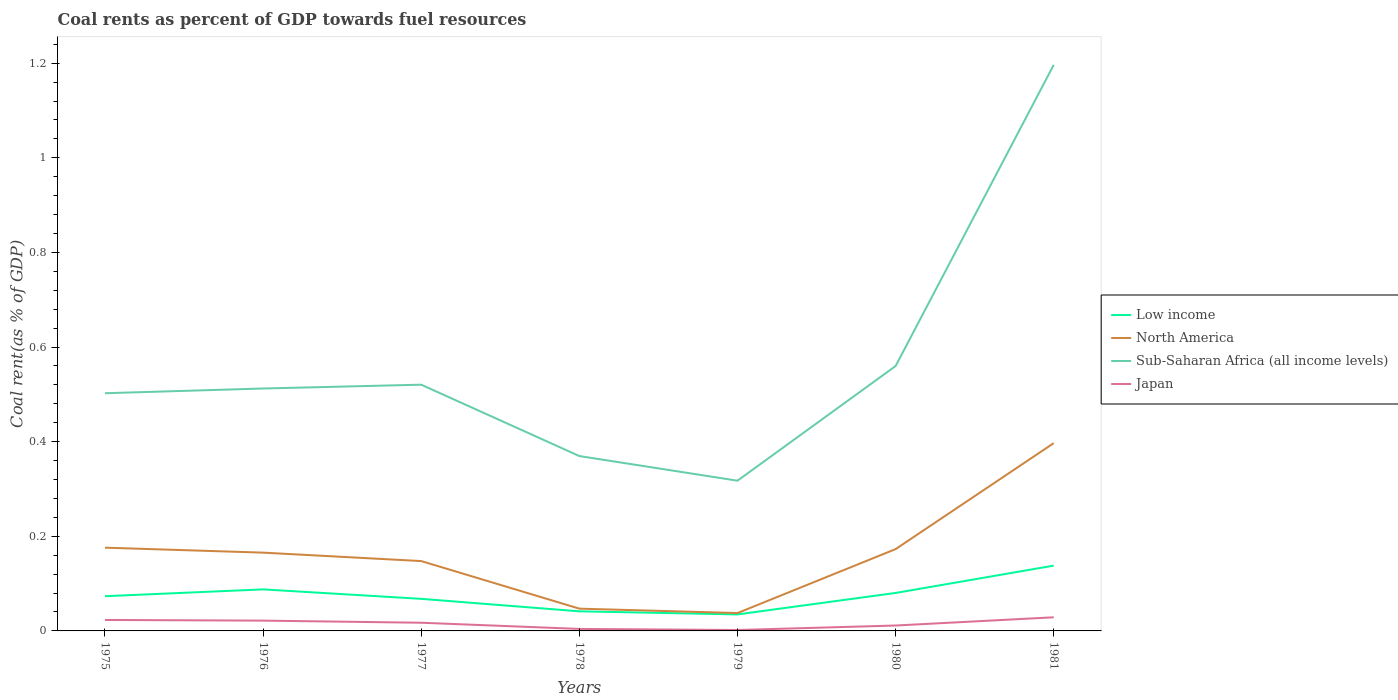Does the line corresponding to Low income intersect with the line corresponding to Japan?
Provide a succinct answer. No. Is the number of lines equal to the number of legend labels?
Make the answer very short. Yes. Across all years, what is the maximum coal rent in Japan?
Make the answer very short. 0. In which year was the coal rent in Sub-Saharan Africa (all income levels) maximum?
Your answer should be compact. 1979. What is the total coal rent in Sub-Saharan Africa (all income levels) in the graph?
Your answer should be very brief. 0.14. What is the difference between the highest and the second highest coal rent in North America?
Keep it short and to the point. 0.36. What is the difference between the highest and the lowest coal rent in North America?
Your response must be concise. 4. How many lines are there?
Ensure brevity in your answer.  4. What is the difference between two consecutive major ticks on the Y-axis?
Ensure brevity in your answer.  0.2. Does the graph contain any zero values?
Provide a short and direct response. No. Where does the legend appear in the graph?
Ensure brevity in your answer.  Center right. How many legend labels are there?
Make the answer very short. 4. How are the legend labels stacked?
Keep it short and to the point. Vertical. What is the title of the graph?
Make the answer very short. Coal rents as percent of GDP towards fuel resources. What is the label or title of the X-axis?
Ensure brevity in your answer.  Years. What is the label or title of the Y-axis?
Your answer should be compact. Coal rent(as % of GDP). What is the Coal rent(as % of GDP) of Low income in 1975?
Make the answer very short. 0.07. What is the Coal rent(as % of GDP) of North America in 1975?
Ensure brevity in your answer.  0.18. What is the Coal rent(as % of GDP) in Sub-Saharan Africa (all income levels) in 1975?
Offer a very short reply. 0.5. What is the Coal rent(as % of GDP) of Japan in 1975?
Offer a very short reply. 0.02. What is the Coal rent(as % of GDP) in Low income in 1976?
Ensure brevity in your answer.  0.09. What is the Coal rent(as % of GDP) of North America in 1976?
Offer a very short reply. 0.17. What is the Coal rent(as % of GDP) of Sub-Saharan Africa (all income levels) in 1976?
Make the answer very short. 0.51. What is the Coal rent(as % of GDP) in Japan in 1976?
Provide a succinct answer. 0.02. What is the Coal rent(as % of GDP) of Low income in 1977?
Your answer should be compact. 0.07. What is the Coal rent(as % of GDP) in North America in 1977?
Offer a very short reply. 0.15. What is the Coal rent(as % of GDP) in Sub-Saharan Africa (all income levels) in 1977?
Your answer should be very brief. 0.52. What is the Coal rent(as % of GDP) of Japan in 1977?
Offer a very short reply. 0.02. What is the Coal rent(as % of GDP) of Low income in 1978?
Make the answer very short. 0.04. What is the Coal rent(as % of GDP) of North America in 1978?
Your response must be concise. 0.05. What is the Coal rent(as % of GDP) of Sub-Saharan Africa (all income levels) in 1978?
Your answer should be very brief. 0.37. What is the Coal rent(as % of GDP) of Japan in 1978?
Offer a terse response. 0. What is the Coal rent(as % of GDP) in Low income in 1979?
Your answer should be compact. 0.03. What is the Coal rent(as % of GDP) of North America in 1979?
Provide a succinct answer. 0.04. What is the Coal rent(as % of GDP) in Sub-Saharan Africa (all income levels) in 1979?
Give a very brief answer. 0.32. What is the Coal rent(as % of GDP) in Japan in 1979?
Your answer should be compact. 0. What is the Coal rent(as % of GDP) in Low income in 1980?
Offer a very short reply. 0.08. What is the Coal rent(as % of GDP) of North America in 1980?
Your answer should be very brief. 0.17. What is the Coal rent(as % of GDP) of Sub-Saharan Africa (all income levels) in 1980?
Your response must be concise. 0.56. What is the Coal rent(as % of GDP) of Japan in 1980?
Keep it short and to the point. 0.01. What is the Coal rent(as % of GDP) in Low income in 1981?
Your answer should be very brief. 0.14. What is the Coal rent(as % of GDP) in North America in 1981?
Keep it short and to the point. 0.4. What is the Coal rent(as % of GDP) in Sub-Saharan Africa (all income levels) in 1981?
Offer a terse response. 1.2. What is the Coal rent(as % of GDP) of Japan in 1981?
Make the answer very short. 0.03. Across all years, what is the maximum Coal rent(as % of GDP) in Low income?
Keep it short and to the point. 0.14. Across all years, what is the maximum Coal rent(as % of GDP) in North America?
Give a very brief answer. 0.4. Across all years, what is the maximum Coal rent(as % of GDP) in Sub-Saharan Africa (all income levels)?
Ensure brevity in your answer.  1.2. Across all years, what is the maximum Coal rent(as % of GDP) of Japan?
Provide a short and direct response. 0.03. Across all years, what is the minimum Coal rent(as % of GDP) in Low income?
Your answer should be very brief. 0.03. Across all years, what is the minimum Coal rent(as % of GDP) in North America?
Give a very brief answer. 0.04. Across all years, what is the minimum Coal rent(as % of GDP) in Sub-Saharan Africa (all income levels)?
Provide a succinct answer. 0.32. Across all years, what is the minimum Coal rent(as % of GDP) of Japan?
Your response must be concise. 0. What is the total Coal rent(as % of GDP) of Low income in the graph?
Your answer should be very brief. 0.52. What is the total Coal rent(as % of GDP) in North America in the graph?
Your answer should be compact. 1.14. What is the total Coal rent(as % of GDP) of Sub-Saharan Africa (all income levels) in the graph?
Provide a succinct answer. 3.98. What is the total Coal rent(as % of GDP) in Japan in the graph?
Make the answer very short. 0.11. What is the difference between the Coal rent(as % of GDP) in Low income in 1975 and that in 1976?
Ensure brevity in your answer.  -0.01. What is the difference between the Coal rent(as % of GDP) in North America in 1975 and that in 1976?
Make the answer very short. 0.01. What is the difference between the Coal rent(as % of GDP) of Sub-Saharan Africa (all income levels) in 1975 and that in 1976?
Provide a short and direct response. -0.01. What is the difference between the Coal rent(as % of GDP) of Japan in 1975 and that in 1976?
Provide a succinct answer. 0. What is the difference between the Coal rent(as % of GDP) in Low income in 1975 and that in 1977?
Give a very brief answer. 0.01. What is the difference between the Coal rent(as % of GDP) in North America in 1975 and that in 1977?
Provide a succinct answer. 0.03. What is the difference between the Coal rent(as % of GDP) in Sub-Saharan Africa (all income levels) in 1975 and that in 1977?
Provide a short and direct response. -0.02. What is the difference between the Coal rent(as % of GDP) of Japan in 1975 and that in 1977?
Offer a very short reply. 0.01. What is the difference between the Coal rent(as % of GDP) of Low income in 1975 and that in 1978?
Offer a terse response. 0.03. What is the difference between the Coal rent(as % of GDP) of North America in 1975 and that in 1978?
Your answer should be very brief. 0.13. What is the difference between the Coal rent(as % of GDP) in Sub-Saharan Africa (all income levels) in 1975 and that in 1978?
Make the answer very short. 0.13. What is the difference between the Coal rent(as % of GDP) in Japan in 1975 and that in 1978?
Make the answer very short. 0.02. What is the difference between the Coal rent(as % of GDP) in Low income in 1975 and that in 1979?
Your response must be concise. 0.04. What is the difference between the Coal rent(as % of GDP) in North America in 1975 and that in 1979?
Give a very brief answer. 0.14. What is the difference between the Coal rent(as % of GDP) of Sub-Saharan Africa (all income levels) in 1975 and that in 1979?
Ensure brevity in your answer.  0.18. What is the difference between the Coal rent(as % of GDP) in Japan in 1975 and that in 1979?
Offer a terse response. 0.02. What is the difference between the Coal rent(as % of GDP) in Low income in 1975 and that in 1980?
Ensure brevity in your answer.  -0.01. What is the difference between the Coal rent(as % of GDP) of North America in 1975 and that in 1980?
Offer a terse response. 0. What is the difference between the Coal rent(as % of GDP) of Sub-Saharan Africa (all income levels) in 1975 and that in 1980?
Your answer should be very brief. -0.06. What is the difference between the Coal rent(as % of GDP) of Japan in 1975 and that in 1980?
Your response must be concise. 0.01. What is the difference between the Coal rent(as % of GDP) in Low income in 1975 and that in 1981?
Your answer should be very brief. -0.06. What is the difference between the Coal rent(as % of GDP) of North America in 1975 and that in 1981?
Your answer should be very brief. -0.22. What is the difference between the Coal rent(as % of GDP) in Sub-Saharan Africa (all income levels) in 1975 and that in 1981?
Make the answer very short. -0.69. What is the difference between the Coal rent(as % of GDP) of Japan in 1975 and that in 1981?
Your response must be concise. -0.01. What is the difference between the Coal rent(as % of GDP) of Low income in 1976 and that in 1977?
Provide a succinct answer. 0.02. What is the difference between the Coal rent(as % of GDP) in North America in 1976 and that in 1977?
Offer a terse response. 0.02. What is the difference between the Coal rent(as % of GDP) of Sub-Saharan Africa (all income levels) in 1976 and that in 1977?
Keep it short and to the point. -0.01. What is the difference between the Coal rent(as % of GDP) of Japan in 1976 and that in 1977?
Offer a very short reply. 0. What is the difference between the Coal rent(as % of GDP) of Low income in 1976 and that in 1978?
Offer a very short reply. 0.05. What is the difference between the Coal rent(as % of GDP) in North America in 1976 and that in 1978?
Your answer should be very brief. 0.12. What is the difference between the Coal rent(as % of GDP) of Sub-Saharan Africa (all income levels) in 1976 and that in 1978?
Give a very brief answer. 0.14. What is the difference between the Coal rent(as % of GDP) in Japan in 1976 and that in 1978?
Provide a succinct answer. 0.02. What is the difference between the Coal rent(as % of GDP) of Low income in 1976 and that in 1979?
Provide a succinct answer. 0.05. What is the difference between the Coal rent(as % of GDP) in North America in 1976 and that in 1979?
Your answer should be compact. 0.13. What is the difference between the Coal rent(as % of GDP) of Sub-Saharan Africa (all income levels) in 1976 and that in 1979?
Your answer should be very brief. 0.19. What is the difference between the Coal rent(as % of GDP) of Japan in 1976 and that in 1979?
Keep it short and to the point. 0.02. What is the difference between the Coal rent(as % of GDP) of Low income in 1976 and that in 1980?
Your response must be concise. 0.01. What is the difference between the Coal rent(as % of GDP) in North America in 1976 and that in 1980?
Keep it short and to the point. -0.01. What is the difference between the Coal rent(as % of GDP) in Sub-Saharan Africa (all income levels) in 1976 and that in 1980?
Offer a very short reply. -0.05. What is the difference between the Coal rent(as % of GDP) of Japan in 1976 and that in 1980?
Your response must be concise. 0.01. What is the difference between the Coal rent(as % of GDP) in Low income in 1976 and that in 1981?
Your answer should be compact. -0.05. What is the difference between the Coal rent(as % of GDP) in North America in 1976 and that in 1981?
Keep it short and to the point. -0.23. What is the difference between the Coal rent(as % of GDP) in Sub-Saharan Africa (all income levels) in 1976 and that in 1981?
Provide a short and direct response. -0.68. What is the difference between the Coal rent(as % of GDP) in Japan in 1976 and that in 1981?
Provide a short and direct response. -0.01. What is the difference between the Coal rent(as % of GDP) in Low income in 1977 and that in 1978?
Keep it short and to the point. 0.03. What is the difference between the Coal rent(as % of GDP) in North America in 1977 and that in 1978?
Ensure brevity in your answer.  0.1. What is the difference between the Coal rent(as % of GDP) in Sub-Saharan Africa (all income levels) in 1977 and that in 1978?
Give a very brief answer. 0.15. What is the difference between the Coal rent(as % of GDP) of Japan in 1977 and that in 1978?
Offer a terse response. 0.01. What is the difference between the Coal rent(as % of GDP) of Low income in 1977 and that in 1979?
Offer a very short reply. 0.03. What is the difference between the Coal rent(as % of GDP) of North America in 1977 and that in 1979?
Your answer should be very brief. 0.11. What is the difference between the Coal rent(as % of GDP) in Sub-Saharan Africa (all income levels) in 1977 and that in 1979?
Keep it short and to the point. 0.2. What is the difference between the Coal rent(as % of GDP) in Japan in 1977 and that in 1979?
Make the answer very short. 0.02. What is the difference between the Coal rent(as % of GDP) in Low income in 1977 and that in 1980?
Your response must be concise. -0.01. What is the difference between the Coal rent(as % of GDP) in North America in 1977 and that in 1980?
Your response must be concise. -0.03. What is the difference between the Coal rent(as % of GDP) in Sub-Saharan Africa (all income levels) in 1977 and that in 1980?
Your response must be concise. -0.04. What is the difference between the Coal rent(as % of GDP) of Japan in 1977 and that in 1980?
Your answer should be compact. 0.01. What is the difference between the Coal rent(as % of GDP) of Low income in 1977 and that in 1981?
Provide a succinct answer. -0.07. What is the difference between the Coal rent(as % of GDP) in North America in 1977 and that in 1981?
Offer a very short reply. -0.25. What is the difference between the Coal rent(as % of GDP) of Sub-Saharan Africa (all income levels) in 1977 and that in 1981?
Provide a succinct answer. -0.68. What is the difference between the Coal rent(as % of GDP) in Japan in 1977 and that in 1981?
Give a very brief answer. -0.01. What is the difference between the Coal rent(as % of GDP) of Low income in 1978 and that in 1979?
Provide a short and direct response. 0.01. What is the difference between the Coal rent(as % of GDP) in North America in 1978 and that in 1979?
Provide a succinct answer. 0.01. What is the difference between the Coal rent(as % of GDP) of Sub-Saharan Africa (all income levels) in 1978 and that in 1979?
Your answer should be compact. 0.05. What is the difference between the Coal rent(as % of GDP) in Japan in 1978 and that in 1979?
Offer a very short reply. 0. What is the difference between the Coal rent(as % of GDP) in Low income in 1978 and that in 1980?
Keep it short and to the point. -0.04. What is the difference between the Coal rent(as % of GDP) of North America in 1978 and that in 1980?
Your answer should be very brief. -0.13. What is the difference between the Coal rent(as % of GDP) in Sub-Saharan Africa (all income levels) in 1978 and that in 1980?
Your answer should be compact. -0.19. What is the difference between the Coal rent(as % of GDP) in Japan in 1978 and that in 1980?
Your response must be concise. -0.01. What is the difference between the Coal rent(as % of GDP) of Low income in 1978 and that in 1981?
Your response must be concise. -0.1. What is the difference between the Coal rent(as % of GDP) of North America in 1978 and that in 1981?
Provide a short and direct response. -0.35. What is the difference between the Coal rent(as % of GDP) in Sub-Saharan Africa (all income levels) in 1978 and that in 1981?
Your answer should be very brief. -0.83. What is the difference between the Coal rent(as % of GDP) in Japan in 1978 and that in 1981?
Provide a succinct answer. -0.02. What is the difference between the Coal rent(as % of GDP) of Low income in 1979 and that in 1980?
Your answer should be compact. -0.05. What is the difference between the Coal rent(as % of GDP) of North America in 1979 and that in 1980?
Your response must be concise. -0.14. What is the difference between the Coal rent(as % of GDP) of Sub-Saharan Africa (all income levels) in 1979 and that in 1980?
Provide a short and direct response. -0.24. What is the difference between the Coal rent(as % of GDP) in Japan in 1979 and that in 1980?
Ensure brevity in your answer.  -0.01. What is the difference between the Coal rent(as % of GDP) of Low income in 1979 and that in 1981?
Your answer should be very brief. -0.1. What is the difference between the Coal rent(as % of GDP) of North America in 1979 and that in 1981?
Your answer should be very brief. -0.36. What is the difference between the Coal rent(as % of GDP) in Sub-Saharan Africa (all income levels) in 1979 and that in 1981?
Keep it short and to the point. -0.88. What is the difference between the Coal rent(as % of GDP) in Japan in 1979 and that in 1981?
Make the answer very short. -0.03. What is the difference between the Coal rent(as % of GDP) of Low income in 1980 and that in 1981?
Ensure brevity in your answer.  -0.06. What is the difference between the Coal rent(as % of GDP) of North America in 1980 and that in 1981?
Give a very brief answer. -0.22. What is the difference between the Coal rent(as % of GDP) of Sub-Saharan Africa (all income levels) in 1980 and that in 1981?
Give a very brief answer. -0.64. What is the difference between the Coal rent(as % of GDP) in Japan in 1980 and that in 1981?
Your answer should be very brief. -0.02. What is the difference between the Coal rent(as % of GDP) of Low income in 1975 and the Coal rent(as % of GDP) of North America in 1976?
Offer a terse response. -0.09. What is the difference between the Coal rent(as % of GDP) of Low income in 1975 and the Coal rent(as % of GDP) of Sub-Saharan Africa (all income levels) in 1976?
Your response must be concise. -0.44. What is the difference between the Coal rent(as % of GDP) of Low income in 1975 and the Coal rent(as % of GDP) of Japan in 1976?
Your answer should be very brief. 0.05. What is the difference between the Coal rent(as % of GDP) of North America in 1975 and the Coal rent(as % of GDP) of Sub-Saharan Africa (all income levels) in 1976?
Provide a succinct answer. -0.34. What is the difference between the Coal rent(as % of GDP) of North America in 1975 and the Coal rent(as % of GDP) of Japan in 1976?
Provide a short and direct response. 0.15. What is the difference between the Coal rent(as % of GDP) in Sub-Saharan Africa (all income levels) in 1975 and the Coal rent(as % of GDP) in Japan in 1976?
Provide a short and direct response. 0.48. What is the difference between the Coal rent(as % of GDP) of Low income in 1975 and the Coal rent(as % of GDP) of North America in 1977?
Ensure brevity in your answer.  -0.07. What is the difference between the Coal rent(as % of GDP) of Low income in 1975 and the Coal rent(as % of GDP) of Sub-Saharan Africa (all income levels) in 1977?
Make the answer very short. -0.45. What is the difference between the Coal rent(as % of GDP) in Low income in 1975 and the Coal rent(as % of GDP) in Japan in 1977?
Offer a very short reply. 0.06. What is the difference between the Coal rent(as % of GDP) in North America in 1975 and the Coal rent(as % of GDP) in Sub-Saharan Africa (all income levels) in 1977?
Ensure brevity in your answer.  -0.34. What is the difference between the Coal rent(as % of GDP) in North America in 1975 and the Coal rent(as % of GDP) in Japan in 1977?
Ensure brevity in your answer.  0.16. What is the difference between the Coal rent(as % of GDP) of Sub-Saharan Africa (all income levels) in 1975 and the Coal rent(as % of GDP) of Japan in 1977?
Give a very brief answer. 0.49. What is the difference between the Coal rent(as % of GDP) of Low income in 1975 and the Coal rent(as % of GDP) of North America in 1978?
Make the answer very short. 0.03. What is the difference between the Coal rent(as % of GDP) in Low income in 1975 and the Coal rent(as % of GDP) in Sub-Saharan Africa (all income levels) in 1978?
Offer a terse response. -0.3. What is the difference between the Coal rent(as % of GDP) in Low income in 1975 and the Coal rent(as % of GDP) in Japan in 1978?
Your response must be concise. 0.07. What is the difference between the Coal rent(as % of GDP) of North America in 1975 and the Coal rent(as % of GDP) of Sub-Saharan Africa (all income levels) in 1978?
Give a very brief answer. -0.19. What is the difference between the Coal rent(as % of GDP) in North America in 1975 and the Coal rent(as % of GDP) in Japan in 1978?
Your answer should be compact. 0.17. What is the difference between the Coal rent(as % of GDP) in Sub-Saharan Africa (all income levels) in 1975 and the Coal rent(as % of GDP) in Japan in 1978?
Ensure brevity in your answer.  0.5. What is the difference between the Coal rent(as % of GDP) in Low income in 1975 and the Coal rent(as % of GDP) in North America in 1979?
Offer a terse response. 0.04. What is the difference between the Coal rent(as % of GDP) in Low income in 1975 and the Coal rent(as % of GDP) in Sub-Saharan Africa (all income levels) in 1979?
Ensure brevity in your answer.  -0.24. What is the difference between the Coal rent(as % of GDP) of Low income in 1975 and the Coal rent(as % of GDP) of Japan in 1979?
Your answer should be compact. 0.07. What is the difference between the Coal rent(as % of GDP) in North America in 1975 and the Coal rent(as % of GDP) in Sub-Saharan Africa (all income levels) in 1979?
Give a very brief answer. -0.14. What is the difference between the Coal rent(as % of GDP) in North America in 1975 and the Coal rent(as % of GDP) in Japan in 1979?
Ensure brevity in your answer.  0.17. What is the difference between the Coal rent(as % of GDP) in Sub-Saharan Africa (all income levels) in 1975 and the Coal rent(as % of GDP) in Japan in 1979?
Give a very brief answer. 0.5. What is the difference between the Coal rent(as % of GDP) in Low income in 1975 and the Coal rent(as % of GDP) in North America in 1980?
Your answer should be very brief. -0.1. What is the difference between the Coal rent(as % of GDP) of Low income in 1975 and the Coal rent(as % of GDP) of Sub-Saharan Africa (all income levels) in 1980?
Make the answer very short. -0.49. What is the difference between the Coal rent(as % of GDP) of Low income in 1975 and the Coal rent(as % of GDP) of Japan in 1980?
Offer a terse response. 0.06. What is the difference between the Coal rent(as % of GDP) of North America in 1975 and the Coal rent(as % of GDP) of Sub-Saharan Africa (all income levels) in 1980?
Provide a succinct answer. -0.38. What is the difference between the Coal rent(as % of GDP) of North America in 1975 and the Coal rent(as % of GDP) of Japan in 1980?
Your answer should be very brief. 0.16. What is the difference between the Coal rent(as % of GDP) in Sub-Saharan Africa (all income levels) in 1975 and the Coal rent(as % of GDP) in Japan in 1980?
Offer a very short reply. 0.49. What is the difference between the Coal rent(as % of GDP) of Low income in 1975 and the Coal rent(as % of GDP) of North America in 1981?
Provide a succinct answer. -0.32. What is the difference between the Coal rent(as % of GDP) of Low income in 1975 and the Coal rent(as % of GDP) of Sub-Saharan Africa (all income levels) in 1981?
Provide a short and direct response. -1.12. What is the difference between the Coal rent(as % of GDP) in Low income in 1975 and the Coal rent(as % of GDP) in Japan in 1981?
Offer a very short reply. 0.04. What is the difference between the Coal rent(as % of GDP) in North America in 1975 and the Coal rent(as % of GDP) in Sub-Saharan Africa (all income levels) in 1981?
Your answer should be compact. -1.02. What is the difference between the Coal rent(as % of GDP) of North America in 1975 and the Coal rent(as % of GDP) of Japan in 1981?
Ensure brevity in your answer.  0.15. What is the difference between the Coal rent(as % of GDP) in Sub-Saharan Africa (all income levels) in 1975 and the Coal rent(as % of GDP) in Japan in 1981?
Offer a terse response. 0.47. What is the difference between the Coal rent(as % of GDP) of Low income in 1976 and the Coal rent(as % of GDP) of North America in 1977?
Provide a succinct answer. -0.06. What is the difference between the Coal rent(as % of GDP) in Low income in 1976 and the Coal rent(as % of GDP) in Sub-Saharan Africa (all income levels) in 1977?
Ensure brevity in your answer.  -0.43. What is the difference between the Coal rent(as % of GDP) in Low income in 1976 and the Coal rent(as % of GDP) in Japan in 1977?
Provide a short and direct response. 0.07. What is the difference between the Coal rent(as % of GDP) in North America in 1976 and the Coal rent(as % of GDP) in Sub-Saharan Africa (all income levels) in 1977?
Give a very brief answer. -0.35. What is the difference between the Coal rent(as % of GDP) in North America in 1976 and the Coal rent(as % of GDP) in Japan in 1977?
Provide a succinct answer. 0.15. What is the difference between the Coal rent(as % of GDP) of Sub-Saharan Africa (all income levels) in 1976 and the Coal rent(as % of GDP) of Japan in 1977?
Give a very brief answer. 0.5. What is the difference between the Coal rent(as % of GDP) of Low income in 1976 and the Coal rent(as % of GDP) of North America in 1978?
Offer a very short reply. 0.04. What is the difference between the Coal rent(as % of GDP) in Low income in 1976 and the Coal rent(as % of GDP) in Sub-Saharan Africa (all income levels) in 1978?
Provide a succinct answer. -0.28. What is the difference between the Coal rent(as % of GDP) in Low income in 1976 and the Coal rent(as % of GDP) in Japan in 1978?
Your answer should be compact. 0.08. What is the difference between the Coal rent(as % of GDP) of North America in 1976 and the Coal rent(as % of GDP) of Sub-Saharan Africa (all income levels) in 1978?
Give a very brief answer. -0.2. What is the difference between the Coal rent(as % of GDP) in North America in 1976 and the Coal rent(as % of GDP) in Japan in 1978?
Make the answer very short. 0.16. What is the difference between the Coal rent(as % of GDP) of Sub-Saharan Africa (all income levels) in 1976 and the Coal rent(as % of GDP) of Japan in 1978?
Ensure brevity in your answer.  0.51. What is the difference between the Coal rent(as % of GDP) in Low income in 1976 and the Coal rent(as % of GDP) in North America in 1979?
Provide a succinct answer. 0.05. What is the difference between the Coal rent(as % of GDP) of Low income in 1976 and the Coal rent(as % of GDP) of Sub-Saharan Africa (all income levels) in 1979?
Make the answer very short. -0.23. What is the difference between the Coal rent(as % of GDP) of Low income in 1976 and the Coal rent(as % of GDP) of Japan in 1979?
Offer a terse response. 0.09. What is the difference between the Coal rent(as % of GDP) of North America in 1976 and the Coal rent(as % of GDP) of Sub-Saharan Africa (all income levels) in 1979?
Your answer should be compact. -0.15. What is the difference between the Coal rent(as % of GDP) in North America in 1976 and the Coal rent(as % of GDP) in Japan in 1979?
Give a very brief answer. 0.16. What is the difference between the Coal rent(as % of GDP) in Sub-Saharan Africa (all income levels) in 1976 and the Coal rent(as % of GDP) in Japan in 1979?
Your answer should be compact. 0.51. What is the difference between the Coal rent(as % of GDP) in Low income in 1976 and the Coal rent(as % of GDP) in North America in 1980?
Provide a short and direct response. -0.09. What is the difference between the Coal rent(as % of GDP) of Low income in 1976 and the Coal rent(as % of GDP) of Sub-Saharan Africa (all income levels) in 1980?
Ensure brevity in your answer.  -0.47. What is the difference between the Coal rent(as % of GDP) of Low income in 1976 and the Coal rent(as % of GDP) of Japan in 1980?
Give a very brief answer. 0.08. What is the difference between the Coal rent(as % of GDP) in North America in 1976 and the Coal rent(as % of GDP) in Sub-Saharan Africa (all income levels) in 1980?
Your response must be concise. -0.39. What is the difference between the Coal rent(as % of GDP) in North America in 1976 and the Coal rent(as % of GDP) in Japan in 1980?
Provide a short and direct response. 0.15. What is the difference between the Coal rent(as % of GDP) of Sub-Saharan Africa (all income levels) in 1976 and the Coal rent(as % of GDP) of Japan in 1980?
Make the answer very short. 0.5. What is the difference between the Coal rent(as % of GDP) of Low income in 1976 and the Coal rent(as % of GDP) of North America in 1981?
Make the answer very short. -0.31. What is the difference between the Coal rent(as % of GDP) in Low income in 1976 and the Coal rent(as % of GDP) in Sub-Saharan Africa (all income levels) in 1981?
Offer a terse response. -1.11. What is the difference between the Coal rent(as % of GDP) in Low income in 1976 and the Coal rent(as % of GDP) in Japan in 1981?
Your answer should be very brief. 0.06. What is the difference between the Coal rent(as % of GDP) of North America in 1976 and the Coal rent(as % of GDP) of Sub-Saharan Africa (all income levels) in 1981?
Your response must be concise. -1.03. What is the difference between the Coal rent(as % of GDP) in North America in 1976 and the Coal rent(as % of GDP) in Japan in 1981?
Offer a terse response. 0.14. What is the difference between the Coal rent(as % of GDP) of Sub-Saharan Africa (all income levels) in 1976 and the Coal rent(as % of GDP) of Japan in 1981?
Your answer should be compact. 0.48. What is the difference between the Coal rent(as % of GDP) in Low income in 1977 and the Coal rent(as % of GDP) in North America in 1978?
Make the answer very short. 0.02. What is the difference between the Coal rent(as % of GDP) in Low income in 1977 and the Coal rent(as % of GDP) in Sub-Saharan Africa (all income levels) in 1978?
Make the answer very short. -0.3. What is the difference between the Coal rent(as % of GDP) of Low income in 1977 and the Coal rent(as % of GDP) of Japan in 1978?
Give a very brief answer. 0.06. What is the difference between the Coal rent(as % of GDP) of North America in 1977 and the Coal rent(as % of GDP) of Sub-Saharan Africa (all income levels) in 1978?
Make the answer very short. -0.22. What is the difference between the Coal rent(as % of GDP) of North America in 1977 and the Coal rent(as % of GDP) of Japan in 1978?
Provide a short and direct response. 0.14. What is the difference between the Coal rent(as % of GDP) of Sub-Saharan Africa (all income levels) in 1977 and the Coal rent(as % of GDP) of Japan in 1978?
Make the answer very short. 0.52. What is the difference between the Coal rent(as % of GDP) of Low income in 1977 and the Coal rent(as % of GDP) of North America in 1979?
Provide a succinct answer. 0.03. What is the difference between the Coal rent(as % of GDP) of Low income in 1977 and the Coal rent(as % of GDP) of Sub-Saharan Africa (all income levels) in 1979?
Your answer should be very brief. -0.25. What is the difference between the Coal rent(as % of GDP) of Low income in 1977 and the Coal rent(as % of GDP) of Japan in 1979?
Give a very brief answer. 0.07. What is the difference between the Coal rent(as % of GDP) in North America in 1977 and the Coal rent(as % of GDP) in Sub-Saharan Africa (all income levels) in 1979?
Make the answer very short. -0.17. What is the difference between the Coal rent(as % of GDP) in North America in 1977 and the Coal rent(as % of GDP) in Japan in 1979?
Your response must be concise. 0.15. What is the difference between the Coal rent(as % of GDP) in Sub-Saharan Africa (all income levels) in 1977 and the Coal rent(as % of GDP) in Japan in 1979?
Give a very brief answer. 0.52. What is the difference between the Coal rent(as % of GDP) in Low income in 1977 and the Coal rent(as % of GDP) in North America in 1980?
Offer a very short reply. -0.11. What is the difference between the Coal rent(as % of GDP) of Low income in 1977 and the Coal rent(as % of GDP) of Sub-Saharan Africa (all income levels) in 1980?
Keep it short and to the point. -0.49. What is the difference between the Coal rent(as % of GDP) of Low income in 1977 and the Coal rent(as % of GDP) of Japan in 1980?
Offer a very short reply. 0.06. What is the difference between the Coal rent(as % of GDP) in North America in 1977 and the Coal rent(as % of GDP) in Sub-Saharan Africa (all income levels) in 1980?
Offer a terse response. -0.41. What is the difference between the Coal rent(as % of GDP) in North America in 1977 and the Coal rent(as % of GDP) in Japan in 1980?
Your answer should be compact. 0.14. What is the difference between the Coal rent(as % of GDP) in Sub-Saharan Africa (all income levels) in 1977 and the Coal rent(as % of GDP) in Japan in 1980?
Give a very brief answer. 0.51. What is the difference between the Coal rent(as % of GDP) in Low income in 1977 and the Coal rent(as % of GDP) in North America in 1981?
Your answer should be compact. -0.33. What is the difference between the Coal rent(as % of GDP) in Low income in 1977 and the Coal rent(as % of GDP) in Sub-Saharan Africa (all income levels) in 1981?
Ensure brevity in your answer.  -1.13. What is the difference between the Coal rent(as % of GDP) of Low income in 1977 and the Coal rent(as % of GDP) of Japan in 1981?
Offer a very short reply. 0.04. What is the difference between the Coal rent(as % of GDP) of North America in 1977 and the Coal rent(as % of GDP) of Sub-Saharan Africa (all income levels) in 1981?
Give a very brief answer. -1.05. What is the difference between the Coal rent(as % of GDP) of North America in 1977 and the Coal rent(as % of GDP) of Japan in 1981?
Offer a terse response. 0.12. What is the difference between the Coal rent(as % of GDP) in Sub-Saharan Africa (all income levels) in 1977 and the Coal rent(as % of GDP) in Japan in 1981?
Your answer should be very brief. 0.49. What is the difference between the Coal rent(as % of GDP) in Low income in 1978 and the Coal rent(as % of GDP) in North America in 1979?
Your answer should be very brief. 0. What is the difference between the Coal rent(as % of GDP) of Low income in 1978 and the Coal rent(as % of GDP) of Sub-Saharan Africa (all income levels) in 1979?
Offer a terse response. -0.28. What is the difference between the Coal rent(as % of GDP) of Low income in 1978 and the Coal rent(as % of GDP) of Japan in 1979?
Provide a succinct answer. 0.04. What is the difference between the Coal rent(as % of GDP) in North America in 1978 and the Coal rent(as % of GDP) in Sub-Saharan Africa (all income levels) in 1979?
Keep it short and to the point. -0.27. What is the difference between the Coal rent(as % of GDP) of North America in 1978 and the Coal rent(as % of GDP) of Japan in 1979?
Provide a succinct answer. 0.05. What is the difference between the Coal rent(as % of GDP) in Sub-Saharan Africa (all income levels) in 1978 and the Coal rent(as % of GDP) in Japan in 1979?
Your answer should be very brief. 0.37. What is the difference between the Coal rent(as % of GDP) of Low income in 1978 and the Coal rent(as % of GDP) of North America in 1980?
Provide a short and direct response. -0.13. What is the difference between the Coal rent(as % of GDP) of Low income in 1978 and the Coal rent(as % of GDP) of Sub-Saharan Africa (all income levels) in 1980?
Your answer should be very brief. -0.52. What is the difference between the Coal rent(as % of GDP) of Low income in 1978 and the Coal rent(as % of GDP) of Japan in 1980?
Keep it short and to the point. 0.03. What is the difference between the Coal rent(as % of GDP) in North America in 1978 and the Coal rent(as % of GDP) in Sub-Saharan Africa (all income levels) in 1980?
Your answer should be compact. -0.51. What is the difference between the Coal rent(as % of GDP) of North America in 1978 and the Coal rent(as % of GDP) of Japan in 1980?
Your answer should be compact. 0.04. What is the difference between the Coal rent(as % of GDP) of Sub-Saharan Africa (all income levels) in 1978 and the Coal rent(as % of GDP) of Japan in 1980?
Provide a short and direct response. 0.36. What is the difference between the Coal rent(as % of GDP) of Low income in 1978 and the Coal rent(as % of GDP) of North America in 1981?
Give a very brief answer. -0.36. What is the difference between the Coal rent(as % of GDP) in Low income in 1978 and the Coal rent(as % of GDP) in Sub-Saharan Africa (all income levels) in 1981?
Your response must be concise. -1.16. What is the difference between the Coal rent(as % of GDP) of Low income in 1978 and the Coal rent(as % of GDP) of Japan in 1981?
Make the answer very short. 0.01. What is the difference between the Coal rent(as % of GDP) of North America in 1978 and the Coal rent(as % of GDP) of Sub-Saharan Africa (all income levels) in 1981?
Provide a succinct answer. -1.15. What is the difference between the Coal rent(as % of GDP) of North America in 1978 and the Coal rent(as % of GDP) of Japan in 1981?
Offer a terse response. 0.02. What is the difference between the Coal rent(as % of GDP) of Sub-Saharan Africa (all income levels) in 1978 and the Coal rent(as % of GDP) of Japan in 1981?
Ensure brevity in your answer.  0.34. What is the difference between the Coal rent(as % of GDP) in Low income in 1979 and the Coal rent(as % of GDP) in North America in 1980?
Offer a very short reply. -0.14. What is the difference between the Coal rent(as % of GDP) in Low income in 1979 and the Coal rent(as % of GDP) in Sub-Saharan Africa (all income levels) in 1980?
Provide a succinct answer. -0.53. What is the difference between the Coal rent(as % of GDP) in Low income in 1979 and the Coal rent(as % of GDP) in Japan in 1980?
Give a very brief answer. 0.02. What is the difference between the Coal rent(as % of GDP) of North America in 1979 and the Coal rent(as % of GDP) of Sub-Saharan Africa (all income levels) in 1980?
Ensure brevity in your answer.  -0.52. What is the difference between the Coal rent(as % of GDP) in North America in 1979 and the Coal rent(as % of GDP) in Japan in 1980?
Your answer should be very brief. 0.03. What is the difference between the Coal rent(as % of GDP) in Sub-Saharan Africa (all income levels) in 1979 and the Coal rent(as % of GDP) in Japan in 1980?
Your response must be concise. 0.31. What is the difference between the Coal rent(as % of GDP) of Low income in 1979 and the Coal rent(as % of GDP) of North America in 1981?
Provide a succinct answer. -0.36. What is the difference between the Coal rent(as % of GDP) of Low income in 1979 and the Coal rent(as % of GDP) of Sub-Saharan Africa (all income levels) in 1981?
Provide a short and direct response. -1.16. What is the difference between the Coal rent(as % of GDP) in Low income in 1979 and the Coal rent(as % of GDP) in Japan in 1981?
Keep it short and to the point. 0.01. What is the difference between the Coal rent(as % of GDP) of North America in 1979 and the Coal rent(as % of GDP) of Sub-Saharan Africa (all income levels) in 1981?
Keep it short and to the point. -1.16. What is the difference between the Coal rent(as % of GDP) in North America in 1979 and the Coal rent(as % of GDP) in Japan in 1981?
Offer a terse response. 0.01. What is the difference between the Coal rent(as % of GDP) in Sub-Saharan Africa (all income levels) in 1979 and the Coal rent(as % of GDP) in Japan in 1981?
Offer a terse response. 0.29. What is the difference between the Coal rent(as % of GDP) of Low income in 1980 and the Coal rent(as % of GDP) of North America in 1981?
Make the answer very short. -0.32. What is the difference between the Coal rent(as % of GDP) in Low income in 1980 and the Coal rent(as % of GDP) in Sub-Saharan Africa (all income levels) in 1981?
Your answer should be very brief. -1.12. What is the difference between the Coal rent(as % of GDP) of Low income in 1980 and the Coal rent(as % of GDP) of Japan in 1981?
Offer a terse response. 0.05. What is the difference between the Coal rent(as % of GDP) in North America in 1980 and the Coal rent(as % of GDP) in Sub-Saharan Africa (all income levels) in 1981?
Provide a succinct answer. -1.02. What is the difference between the Coal rent(as % of GDP) in North America in 1980 and the Coal rent(as % of GDP) in Japan in 1981?
Offer a very short reply. 0.14. What is the difference between the Coal rent(as % of GDP) of Sub-Saharan Africa (all income levels) in 1980 and the Coal rent(as % of GDP) of Japan in 1981?
Offer a terse response. 0.53. What is the average Coal rent(as % of GDP) in Low income per year?
Make the answer very short. 0.07. What is the average Coal rent(as % of GDP) of North America per year?
Give a very brief answer. 0.16. What is the average Coal rent(as % of GDP) of Sub-Saharan Africa (all income levels) per year?
Offer a very short reply. 0.57. What is the average Coal rent(as % of GDP) of Japan per year?
Offer a terse response. 0.02. In the year 1975, what is the difference between the Coal rent(as % of GDP) of Low income and Coal rent(as % of GDP) of North America?
Keep it short and to the point. -0.1. In the year 1975, what is the difference between the Coal rent(as % of GDP) in Low income and Coal rent(as % of GDP) in Sub-Saharan Africa (all income levels)?
Offer a terse response. -0.43. In the year 1975, what is the difference between the Coal rent(as % of GDP) in Low income and Coal rent(as % of GDP) in Japan?
Your answer should be very brief. 0.05. In the year 1975, what is the difference between the Coal rent(as % of GDP) of North America and Coal rent(as % of GDP) of Sub-Saharan Africa (all income levels)?
Your answer should be compact. -0.33. In the year 1975, what is the difference between the Coal rent(as % of GDP) in North America and Coal rent(as % of GDP) in Japan?
Keep it short and to the point. 0.15. In the year 1975, what is the difference between the Coal rent(as % of GDP) of Sub-Saharan Africa (all income levels) and Coal rent(as % of GDP) of Japan?
Make the answer very short. 0.48. In the year 1976, what is the difference between the Coal rent(as % of GDP) in Low income and Coal rent(as % of GDP) in North America?
Provide a short and direct response. -0.08. In the year 1976, what is the difference between the Coal rent(as % of GDP) in Low income and Coal rent(as % of GDP) in Sub-Saharan Africa (all income levels)?
Provide a succinct answer. -0.42. In the year 1976, what is the difference between the Coal rent(as % of GDP) of Low income and Coal rent(as % of GDP) of Japan?
Your answer should be compact. 0.07. In the year 1976, what is the difference between the Coal rent(as % of GDP) in North America and Coal rent(as % of GDP) in Sub-Saharan Africa (all income levels)?
Offer a terse response. -0.35. In the year 1976, what is the difference between the Coal rent(as % of GDP) in North America and Coal rent(as % of GDP) in Japan?
Your answer should be compact. 0.14. In the year 1976, what is the difference between the Coal rent(as % of GDP) of Sub-Saharan Africa (all income levels) and Coal rent(as % of GDP) of Japan?
Give a very brief answer. 0.49. In the year 1977, what is the difference between the Coal rent(as % of GDP) in Low income and Coal rent(as % of GDP) in North America?
Offer a very short reply. -0.08. In the year 1977, what is the difference between the Coal rent(as % of GDP) in Low income and Coal rent(as % of GDP) in Sub-Saharan Africa (all income levels)?
Ensure brevity in your answer.  -0.45. In the year 1977, what is the difference between the Coal rent(as % of GDP) of Low income and Coal rent(as % of GDP) of Japan?
Provide a succinct answer. 0.05. In the year 1977, what is the difference between the Coal rent(as % of GDP) in North America and Coal rent(as % of GDP) in Sub-Saharan Africa (all income levels)?
Your answer should be very brief. -0.37. In the year 1977, what is the difference between the Coal rent(as % of GDP) of North America and Coal rent(as % of GDP) of Japan?
Provide a succinct answer. 0.13. In the year 1977, what is the difference between the Coal rent(as % of GDP) of Sub-Saharan Africa (all income levels) and Coal rent(as % of GDP) of Japan?
Offer a very short reply. 0.5. In the year 1978, what is the difference between the Coal rent(as % of GDP) in Low income and Coal rent(as % of GDP) in North America?
Offer a terse response. -0.01. In the year 1978, what is the difference between the Coal rent(as % of GDP) of Low income and Coal rent(as % of GDP) of Sub-Saharan Africa (all income levels)?
Provide a short and direct response. -0.33. In the year 1978, what is the difference between the Coal rent(as % of GDP) in Low income and Coal rent(as % of GDP) in Japan?
Your answer should be very brief. 0.04. In the year 1978, what is the difference between the Coal rent(as % of GDP) in North America and Coal rent(as % of GDP) in Sub-Saharan Africa (all income levels)?
Provide a succinct answer. -0.32. In the year 1978, what is the difference between the Coal rent(as % of GDP) of North America and Coal rent(as % of GDP) of Japan?
Make the answer very short. 0.04. In the year 1978, what is the difference between the Coal rent(as % of GDP) in Sub-Saharan Africa (all income levels) and Coal rent(as % of GDP) in Japan?
Your answer should be compact. 0.37. In the year 1979, what is the difference between the Coal rent(as % of GDP) in Low income and Coal rent(as % of GDP) in North America?
Your answer should be compact. -0. In the year 1979, what is the difference between the Coal rent(as % of GDP) of Low income and Coal rent(as % of GDP) of Sub-Saharan Africa (all income levels)?
Ensure brevity in your answer.  -0.28. In the year 1979, what is the difference between the Coal rent(as % of GDP) of Low income and Coal rent(as % of GDP) of Japan?
Give a very brief answer. 0.03. In the year 1979, what is the difference between the Coal rent(as % of GDP) of North America and Coal rent(as % of GDP) of Sub-Saharan Africa (all income levels)?
Give a very brief answer. -0.28. In the year 1979, what is the difference between the Coal rent(as % of GDP) of North America and Coal rent(as % of GDP) of Japan?
Ensure brevity in your answer.  0.04. In the year 1979, what is the difference between the Coal rent(as % of GDP) in Sub-Saharan Africa (all income levels) and Coal rent(as % of GDP) in Japan?
Offer a terse response. 0.32. In the year 1980, what is the difference between the Coal rent(as % of GDP) in Low income and Coal rent(as % of GDP) in North America?
Provide a short and direct response. -0.09. In the year 1980, what is the difference between the Coal rent(as % of GDP) of Low income and Coal rent(as % of GDP) of Sub-Saharan Africa (all income levels)?
Give a very brief answer. -0.48. In the year 1980, what is the difference between the Coal rent(as % of GDP) in Low income and Coal rent(as % of GDP) in Japan?
Keep it short and to the point. 0.07. In the year 1980, what is the difference between the Coal rent(as % of GDP) in North America and Coal rent(as % of GDP) in Sub-Saharan Africa (all income levels)?
Offer a terse response. -0.39. In the year 1980, what is the difference between the Coal rent(as % of GDP) of North America and Coal rent(as % of GDP) of Japan?
Your answer should be compact. 0.16. In the year 1980, what is the difference between the Coal rent(as % of GDP) in Sub-Saharan Africa (all income levels) and Coal rent(as % of GDP) in Japan?
Provide a short and direct response. 0.55. In the year 1981, what is the difference between the Coal rent(as % of GDP) in Low income and Coal rent(as % of GDP) in North America?
Provide a succinct answer. -0.26. In the year 1981, what is the difference between the Coal rent(as % of GDP) of Low income and Coal rent(as % of GDP) of Sub-Saharan Africa (all income levels)?
Give a very brief answer. -1.06. In the year 1981, what is the difference between the Coal rent(as % of GDP) of Low income and Coal rent(as % of GDP) of Japan?
Your answer should be compact. 0.11. In the year 1981, what is the difference between the Coal rent(as % of GDP) in North America and Coal rent(as % of GDP) in Sub-Saharan Africa (all income levels)?
Offer a very short reply. -0.8. In the year 1981, what is the difference between the Coal rent(as % of GDP) of North America and Coal rent(as % of GDP) of Japan?
Your response must be concise. 0.37. In the year 1981, what is the difference between the Coal rent(as % of GDP) of Sub-Saharan Africa (all income levels) and Coal rent(as % of GDP) of Japan?
Make the answer very short. 1.17. What is the ratio of the Coal rent(as % of GDP) of Low income in 1975 to that in 1976?
Give a very brief answer. 0.84. What is the ratio of the Coal rent(as % of GDP) of North America in 1975 to that in 1976?
Offer a terse response. 1.06. What is the ratio of the Coal rent(as % of GDP) of Sub-Saharan Africa (all income levels) in 1975 to that in 1976?
Provide a succinct answer. 0.98. What is the ratio of the Coal rent(as % of GDP) of Japan in 1975 to that in 1976?
Offer a terse response. 1.06. What is the ratio of the Coal rent(as % of GDP) of Low income in 1975 to that in 1977?
Keep it short and to the point. 1.08. What is the ratio of the Coal rent(as % of GDP) of North America in 1975 to that in 1977?
Give a very brief answer. 1.19. What is the ratio of the Coal rent(as % of GDP) in Sub-Saharan Africa (all income levels) in 1975 to that in 1977?
Provide a short and direct response. 0.97. What is the ratio of the Coal rent(as % of GDP) in Japan in 1975 to that in 1977?
Ensure brevity in your answer.  1.34. What is the ratio of the Coal rent(as % of GDP) in Low income in 1975 to that in 1978?
Offer a very short reply. 1.77. What is the ratio of the Coal rent(as % of GDP) of North America in 1975 to that in 1978?
Your response must be concise. 3.74. What is the ratio of the Coal rent(as % of GDP) of Sub-Saharan Africa (all income levels) in 1975 to that in 1978?
Make the answer very short. 1.36. What is the ratio of the Coal rent(as % of GDP) in Japan in 1975 to that in 1978?
Give a very brief answer. 5.46. What is the ratio of the Coal rent(as % of GDP) of Low income in 1975 to that in 1979?
Your answer should be very brief. 2.1. What is the ratio of the Coal rent(as % of GDP) of North America in 1975 to that in 1979?
Offer a terse response. 4.66. What is the ratio of the Coal rent(as % of GDP) of Sub-Saharan Africa (all income levels) in 1975 to that in 1979?
Give a very brief answer. 1.58. What is the ratio of the Coal rent(as % of GDP) of Japan in 1975 to that in 1979?
Provide a short and direct response. 11.66. What is the ratio of the Coal rent(as % of GDP) in Low income in 1975 to that in 1980?
Your response must be concise. 0.91. What is the ratio of the Coal rent(as % of GDP) of North America in 1975 to that in 1980?
Your response must be concise. 1.02. What is the ratio of the Coal rent(as % of GDP) of Sub-Saharan Africa (all income levels) in 1975 to that in 1980?
Provide a short and direct response. 0.9. What is the ratio of the Coal rent(as % of GDP) of Japan in 1975 to that in 1980?
Make the answer very short. 2.03. What is the ratio of the Coal rent(as % of GDP) of Low income in 1975 to that in 1981?
Your answer should be very brief. 0.53. What is the ratio of the Coal rent(as % of GDP) of North America in 1975 to that in 1981?
Offer a terse response. 0.44. What is the ratio of the Coal rent(as % of GDP) of Sub-Saharan Africa (all income levels) in 1975 to that in 1981?
Provide a short and direct response. 0.42. What is the ratio of the Coal rent(as % of GDP) of Japan in 1975 to that in 1981?
Keep it short and to the point. 0.8. What is the ratio of the Coal rent(as % of GDP) of Low income in 1976 to that in 1977?
Your answer should be very brief. 1.3. What is the ratio of the Coal rent(as % of GDP) in North America in 1976 to that in 1977?
Offer a very short reply. 1.12. What is the ratio of the Coal rent(as % of GDP) in Sub-Saharan Africa (all income levels) in 1976 to that in 1977?
Your response must be concise. 0.98. What is the ratio of the Coal rent(as % of GDP) of Japan in 1976 to that in 1977?
Your answer should be compact. 1.26. What is the ratio of the Coal rent(as % of GDP) of Low income in 1976 to that in 1978?
Provide a short and direct response. 2.12. What is the ratio of the Coal rent(as % of GDP) of North America in 1976 to that in 1978?
Offer a terse response. 3.51. What is the ratio of the Coal rent(as % of GDP) of Sub-Saharan Africa (all income levels) in 1976 to that in 1978?
Offer a terse response. 1.39. What is the ratio of the Coal rent(as % of GDP) of Japan in 1976 to that in 1978?
Give a very brief answer. 5.13. What is the ratio of the Coal rent(as % of GDP) of Low income in 1976 to that in 1979?
Your response must be concise. 2.52. What is the ratio of the Coal rent(as % of GDP) of North America in 1976 to that in 1979?
Provide a succinct answer. 4.38. What is the ratio of the Coal rent(as % of GDP) in Sub-Saharan Africa (all income levels) in 1976 to that in 1979?
Offer a terse response. 1.61. What is the ratio of the Coal rent(as % of GDP) in Japan in 1976 to that in 1979?
Offer a terse response. 10.95. What is the ratio of the Coal rent(as % of GDP) of Low income in 1976 to that in 1980?
Your answer should be compact. 1.09. What is the ratio of the Coal rent(as % of GDP) in North America in 1976 to that in 1980?
Provide a short and direct response. 0.96. What is the ratio of the Coal rent(as % of GDP) of Sub-Saharan Africa (all income levels) in 1976 to that in 1980?
Provide a succinct answer. 0.92. What is the ratio of the Coal rent(as % of GDP) in Japan in 1976 to that in 1980?
Keep it short and to the point. 1.9. What is the ratio of the Coal rent(as % of GDP) in Low income in 1976 to that in 1981?
Ensure brevity in your answer.  0.64. What is the ratio of the Coal rent(as % of GDP) in North America in 1976 to that in 1981?
Provide a short and direct response. 0.42. What is the ratio of the Coal rent(as % of GDP) of Sub-Saharan Africa (all income levels) in 1976 to that in 1981?
Provide a succinct answer. 0.43. What is the ratio of the Coal rent(as % of GDP) in Japan in 1976 to that in 1981?
Keep it short and to the point. 0.76. What is the ratio of the Coal rent(as % of GDP) of Low income in 1977 to that in 1978?
Give a very brief answer. 1.64. What is the ratio of the Coal rent(as % of GDP) in North America in 1977 to that in 1978?
Provide a succinct answer. 3.14. What is the ratio of the Coal rent(as % of GDP) in Sub-Saharan Africa (all income levels) in 1977 to that in 1978?
Keep it short and to the point. 1.41. What is the ratio of the Coal rent(as % of GDP) of Japan in 1977 to that in 1978?
Keep it short and to the point. 4.08. What is the ratio of the Coal rent(as % of GDP) of Low income in 1977 to that in 1979?
Your answer should be compact. 1.94. What is the ratio of the Coal rent(as % of GDP) in North America in 1977 to that in 1979?
Make the answer very short. 3.91. What is the ratio of the Coal rent(as % of GDP) in Sub-Saharan Africa (all income levels) in 1977 to that in 1979?
Offer a very short reply. 1.64. What is the ratio of the Coal rent(as % of GDP) of Japan in 1977 to that in 1979?
Provide a short and direct response. 8.71. What is the ratio of the Coal rent(as % of GDP) of Low income in 1977 to that in 1980?
Give a very brief answer. 0.84. What is the ratio of the Coal rent(as % of GDP) of North America in 1977 to that in 1980?
Provide a short and direct response. 0.85. What is the ratio of the Coal rent(as % of GDP) in Sub-Saharan Africa (all income levels) in 1977 to that in 1980?
Give a very brief answer. 0.93. What is the ratio of the Coal rent(as % of GDP) in Japan in 1977 to that in 1980?
Your answer should be very brief. 1.51. What is the ratio of the Coal rent(as % of GDP) in Low income in 1977 to that in 1981?
Make the answer very short. 0.49. What is the ratio of the Coal rent(as % of GDP) of North America in 1977 to that in 1981?
Your answer should be compact. 0.37. What is the ratio of the Coal rent(as % of GDP) in Sub-Saharan Africa (all income levels) in 1977 to that in 1981?
Offer a terse response. 0.43. What is the ratio of the Coal rent(as % of GDP) of Japan in 1977 to that in 1981?
Ensure brevity in your answer.  0.6. What is the ratio of the Coal rent(as % of GDP) in Low income in 1978 to that in 1979?
Your answer should be compact. 1.19. What is the ratio of the Coal rent(as % of GDP) in North America in 1978 to that in 1979?
Your answer should be compact. 1.25. What is the ratio of the Coal rent(as % of GDP) in Sub-Saharan Africa (all income levels) in 1978 to that in 1979?
Provide a short and direct response. 1.16. What is the ratio of the Coal rent(as % of GDP) in Japan in 1978 to that in 1979?
Provide a short and direct response. 2.13. What is the ratio of the Coal rent(as % of GDP) of Low income in 1978 to that in 1980?
Your answer should be very brief. 0.52. What is the ratio of the Coal rent(as % of GDP) of North America in 1978 to that in 1980?
Make the answer very short. 0.27. What is the ratio of the Coal rent(as % of GDP) of Sub-Saharan Africa (all income levels) in 1978 to that in 1980?
Your response must be concise. 0.66. What is the ratio of the Coal rent(as % of GDP) in Japan in 1978 to that in 1980?
Offer a terse response. 0.37. What is the ratio of the Coal rent(as % of GDP) of North America in 1978 to that in 1981?
Provide a succinct answer. 0.12. What is the ratio of the Coal rent(as % of GDP) in Sub-Saharan Africa (all income levels) in 1978 to that in 1981?
Offer a terse response. 0.31. What is the ratio of the Coal rent(as % of GDP) of Japan in 1978 to that in 1981?
Offer a very short reply. 0.15. What is the ratio of the Coal rent(as % of GDP) in Low income in 1979 to that in 1980?
Make the answer very short. 0.43. What is the ratio of the Coal rent(as % of GDP) of North America in 1979 to that in 1980?
Ensure brevity in your answer.  0.22. What is the ratio of the Coal rent(as % of GDP) of Sub-Saharan Africa (all income levels) in 1979 to that in 1980?
Make the answer very short. 0.57. What is the ratio of the Coal rent(as % of GDP) in Japan in 1979 to that in 1980?
Provide a succinct answer. 0.17. What is the ratio of the Coal rent(as % of GDP) of Low income in 1979 to that in 1981?
Offer a very short reply. 0.25. What is the ratio of the Coal rent(as % of GDP) in North America in 1979 to that in 1981?
Make the answer very short. 0.1. What is the ratio of the Coal rent(as % of GDP) of Sub-Saharan Africa (all income levels) in 1979 to that in 1981?
Give a very brief answer. 0.27. What is the ratio of the Coal rent(as % of GDP) of Japan in 1979 to that in 1981?
Make the answer very short. 0.07. What is the ratio of the Coal rent(as % of GDP) of Low income in 1980 to that in 1981?
Provide a succinct answer. 0.58. What is the ratio of the Coal rent(as % of GDP) in North America in 1980 to that in 1981?
Provide a succinct answer. 0.44. What is the ratio of the Coal rent(as % of GDP) of Sub-Saharan Africa (all income levels) in 1980 to that in 1981?
Ensure brevity in your answer.  0.47. What is the ratio of the Coal rent(as % of GDP) of Japan in 1980 to that in 1981?
Give a very brief answer. 0.4. What is the difference between the highest and the second highest Coal rent(as % of GDP) in Low income?
Give a very brief answer. 0.05. What is the difference between the highest and the second highest Coal rent(as % of GDP) of North America?
Provide a short and direct response. 0.22. What is the difference between the highest and the second highest Coal rent(as % of GDP) of Sub-Saharan Africa (all income levels)?
Provide a succinct answer. 0.64. What is the difference between the highest and the second highest Coal rent(as % of GDP) of Japan?
Make the answer very short. 0.01. What is the difference between the highest and the lowest Coal rent(as % of GDP) of Low income?
Make the answer very short. 0.1. What is the difference between the highest and the lowest Coal rent(as % of GDP) of North America?
Give a very brief answer. 0.36. What is the difference between the highest and the lowest Coal rent(as % of GDP) of Sub-Saharan Africa (all income levels)?
Give a very brief answer. 0.88. What is the difference between the highest and the lowest Coal rent(as % of GDP) in Japan?
Offer a very short reply. 0.03. 